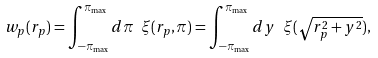Convert formula to latex. <formula><loc_0><loc_0><loc_500><loc_500>w _ { p } ( r _ { p } ) = \int _ { - \pi _ { \max } } ^ { \pi _ { \max } } d \pi \ \xi ( r _ { p } , \pi ) = \int _ { - \pi _ { \max } } ^ { \pi _ { \max } } d y \ \xi ( \sqrt { r _ { p } ^ { 2 } + y ^ { 2 } } ) ,</formula> 